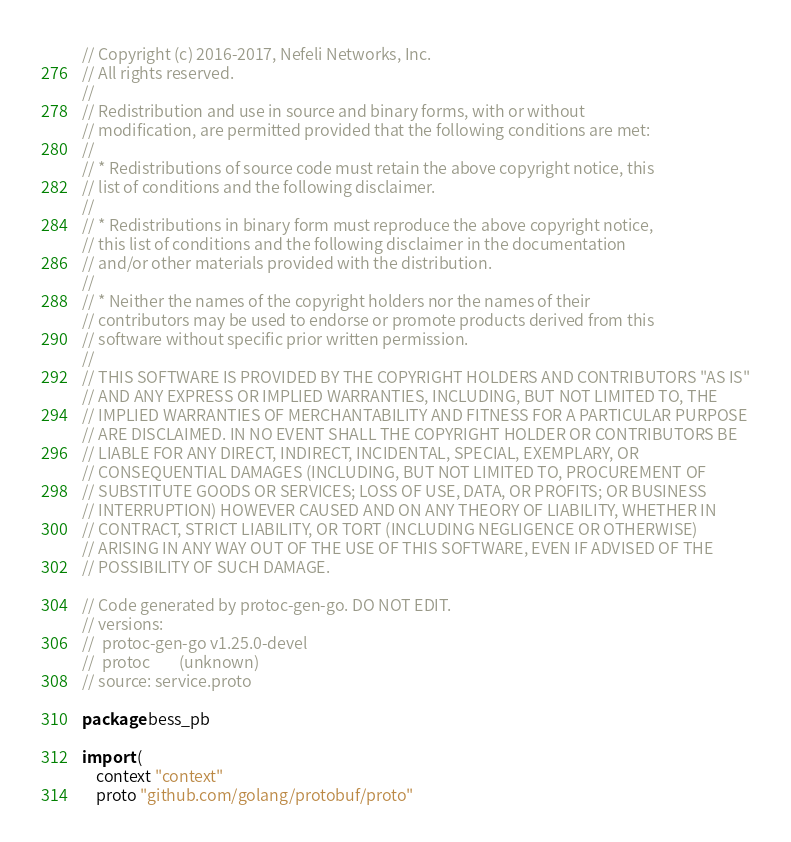<code> <loc_0><loc_0><loc_500><loc_500><_Go_>// Copyright (c) 2016-2017, Nefeli Networks, Inc.
// All rights reserved.
//
// Redistribution and use in source and binary forms, with or without
// modification, are permitted provided that the following conditions are met:
//
// * Redistributions of source code must retain the above copyright notice, this
// list of conditions and the following disclaimer.
//
// * Redistributions in binary form must reproduce the above copyright notice,
// this list of conditions and the following disclaimer in the documentation
// and/or other materials provided with the distribution.
//
// * Neither the names of the copyright holders nor the names of their
// contributors may be used to endorse or promote products derived from this
// software without specific prior written permission.
//
// THIS SOFTWARE IS PROVIDED BY THE COPYRIGHT HOLDERS AND CONTRIBUTORS "AS IS"
// AND ANY EXPRESS OR IMPLIED WARRANTIES, INCLUDING, BUT NOT LIMITED TO, THE
// IMPLIED WARRANTIES OF MERCHANTABILITY AND FITNESS FOR A PARTICULAR PURPOSE
// ARE DISCLAIMED. IN NO EVENT SHALL THE COPYRIGHT HOLDER OR CONTRIBUTORS BE
// LIABLE FOR ANY DIRECT, INDIRECT, INCIDENTAL, SPECIAL, EXEMPLARY, OR
// CONSEQUENTIAL DAMAGES (INCLUDING, BUT NOT LIMITED TO, PROCUREMENT OF
// SUBSTITUTE GOODS OR SERVICES; LOSS OF USE, DATA, OR PROFITS; OR BUSINESS
// INTERRUPTION) HOWEVER CAUSED AND ON ANY THEORY OF LIABILITY, WHETHER IN
// CONTRACT, STRICT LIABILITY, OR TORT (INCLUDING NEGLIGENCE OR OTHERWISE)
// ARISING IN ANY WAY OUT OF THE USE OF THIS SOFTWARE, EVEN IF ADVISED OF THE
// POSSIBILITY OF SUCH DAMAGE.

// Code generated by protoc-gen-go. DO NOT EDIT.
// versions:
// 	protoc-gen-go v1.25.0-devel
// 	protoc        (unknown)
// source: service.proto

package bess_pb

import (
	context "context"
	proto "github.com/golang/protobuf/proto"</code> 